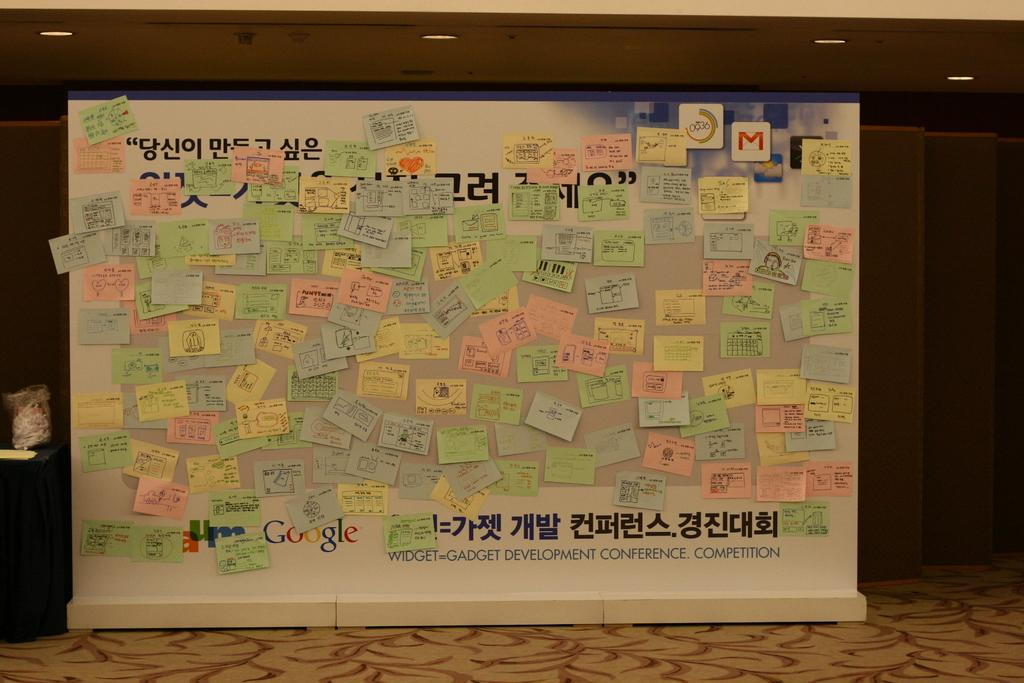<image>
Summarize the visual content of the image. a bunch of sticky notes above the word conference 